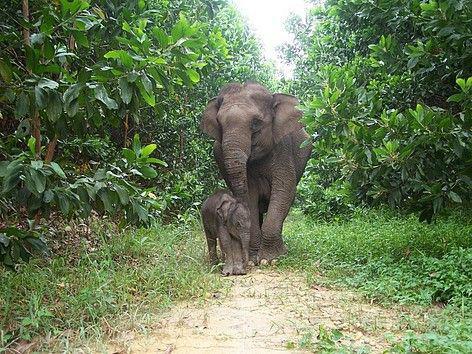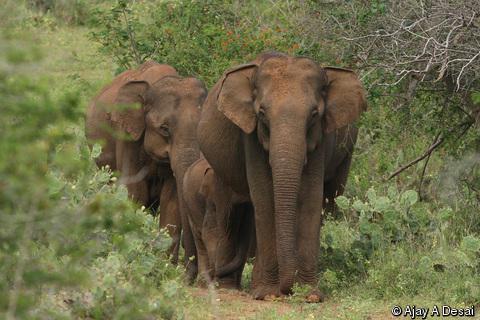The first image is the image on the left, the second image is the image on the right. For the images shown, is this caption "The right image shows an elephant with large tusks." true? Answer yes or no. No. 